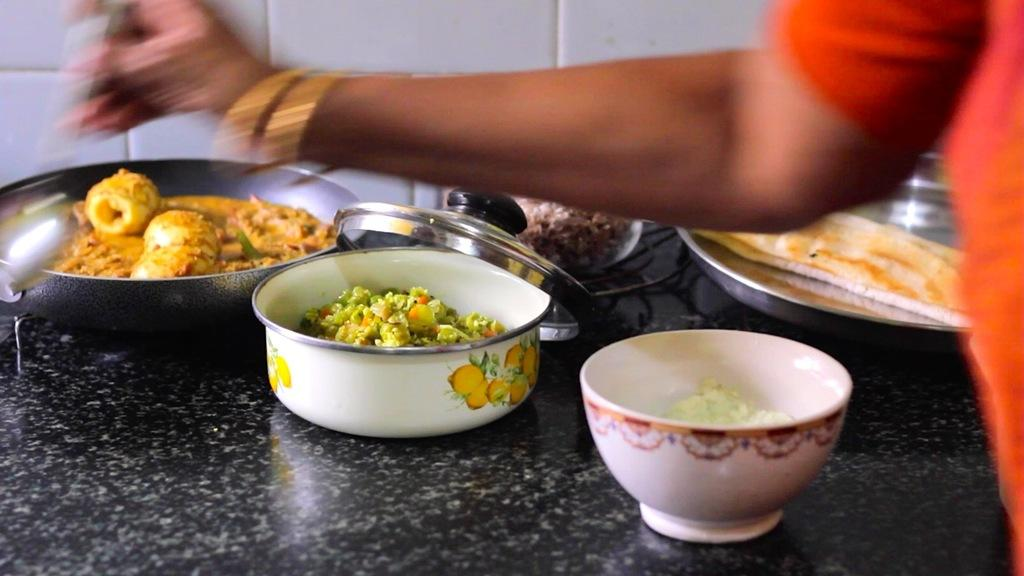What is present on the table in the image? There are food items on the table in the image. Can you describe the person in front of the table? Unfortunately, the image does not provide enough information to describe the person in front of the table. What language is the jelly speaking on the scale in the image? There is no jelly or scale present in the image. 